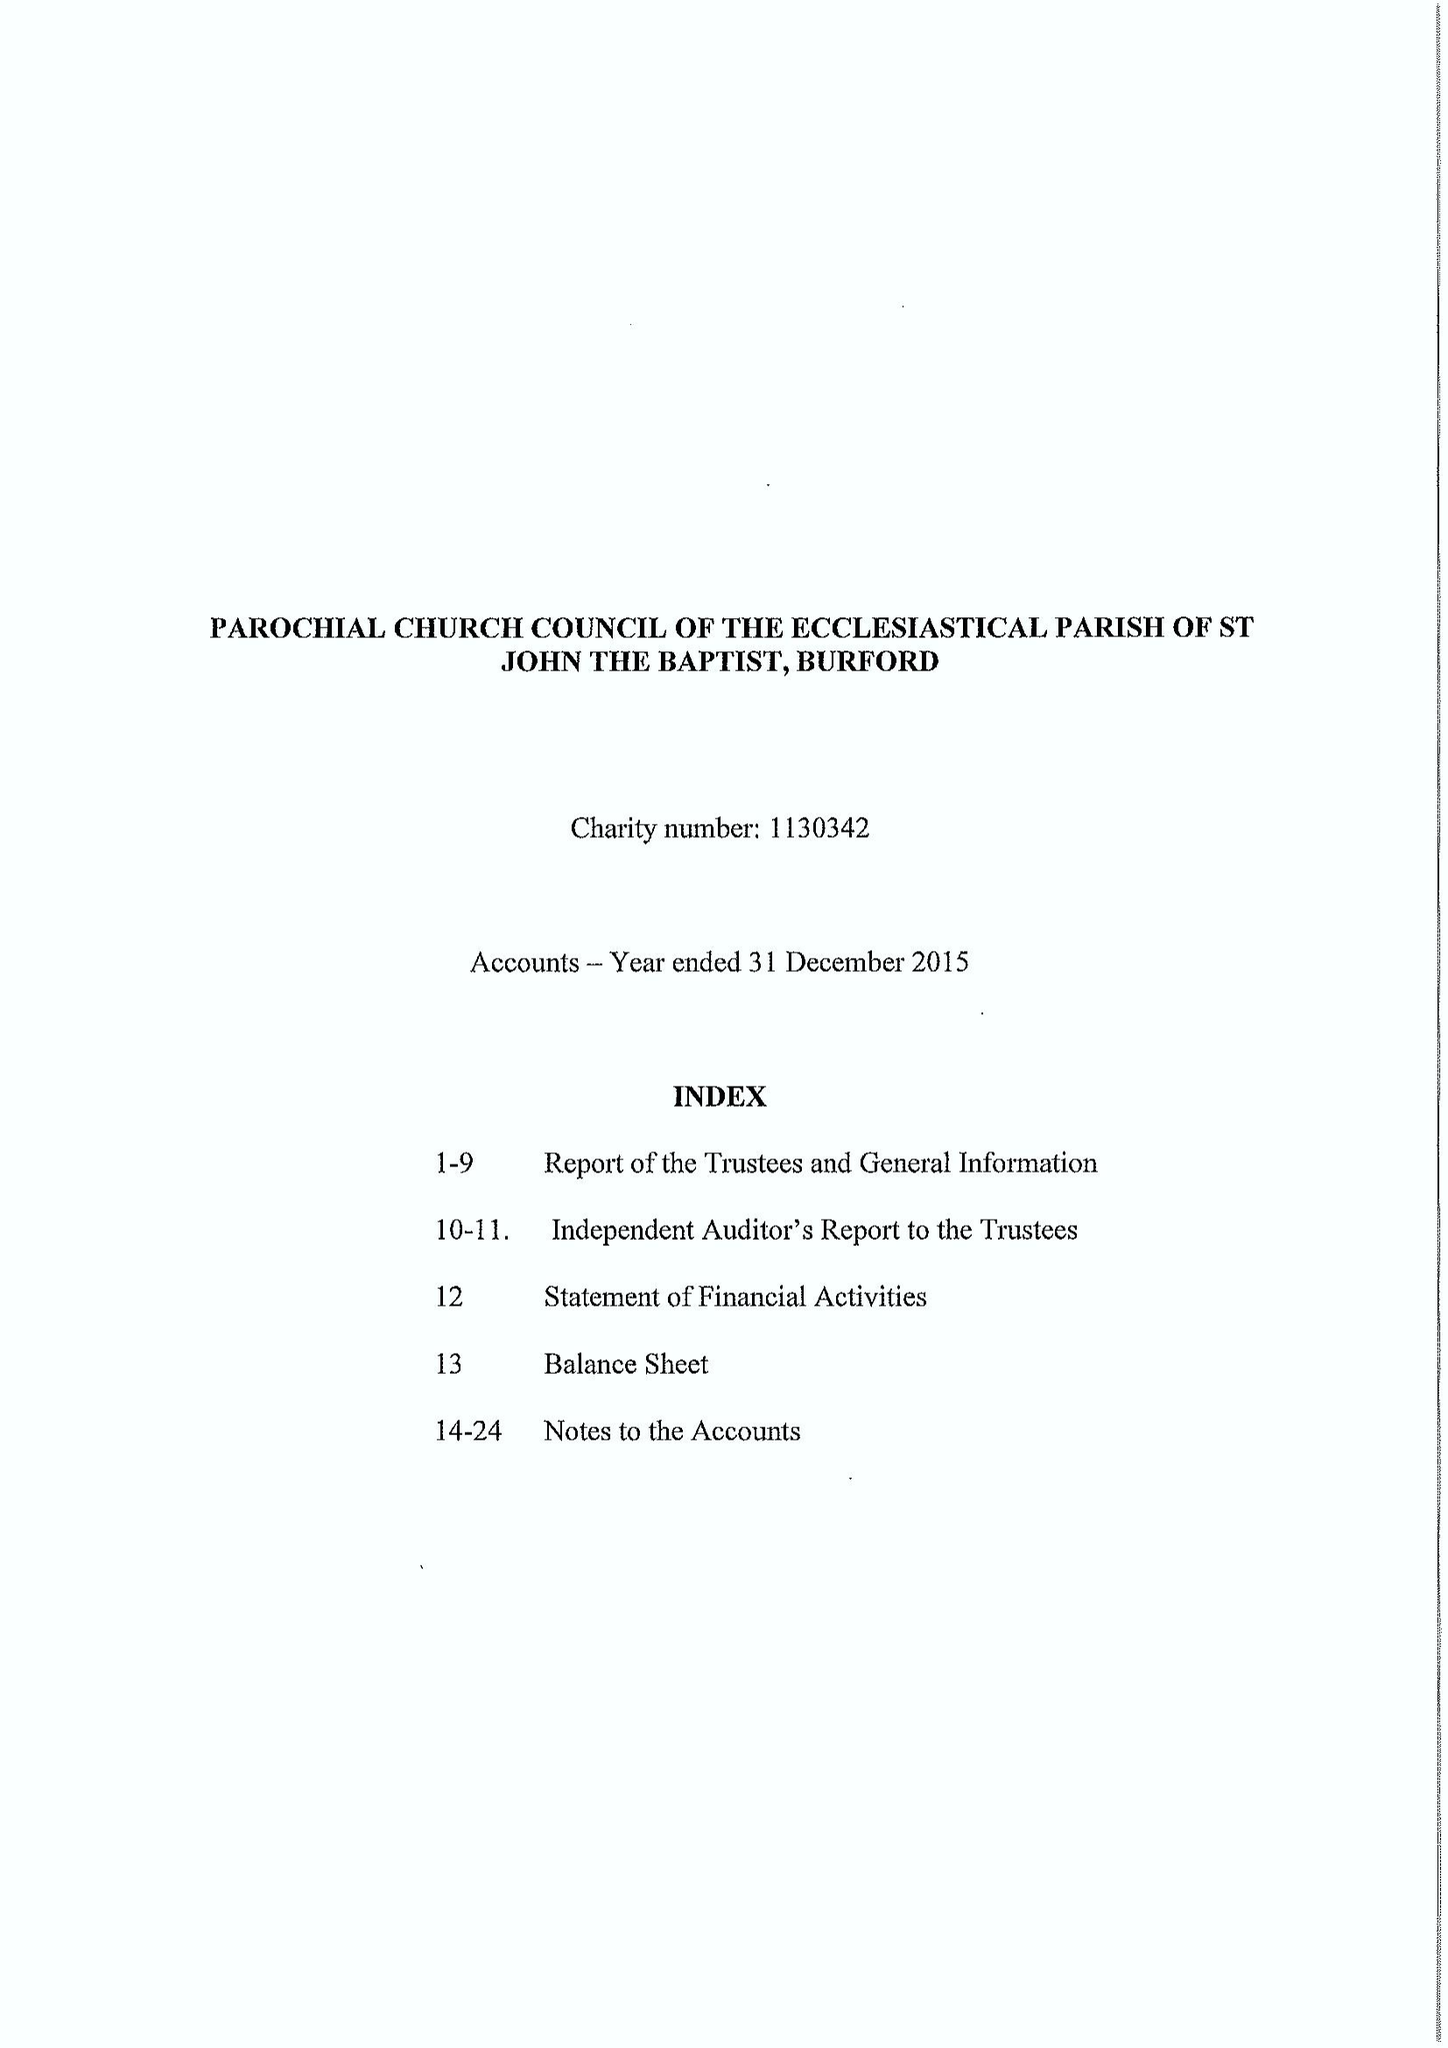What is the value for the income_annually_in_british_pounds?
Answer the question using a single word or phrase. 2481912.00 